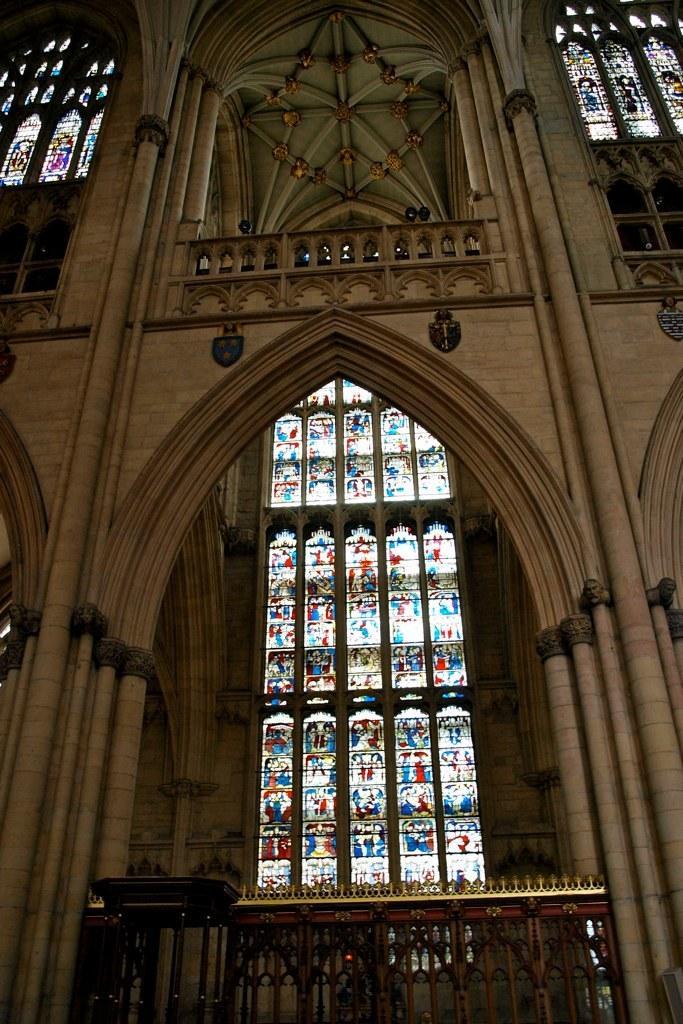Can you describe this image briefly? There is a building which has few glasses and some designs on it in the background. 